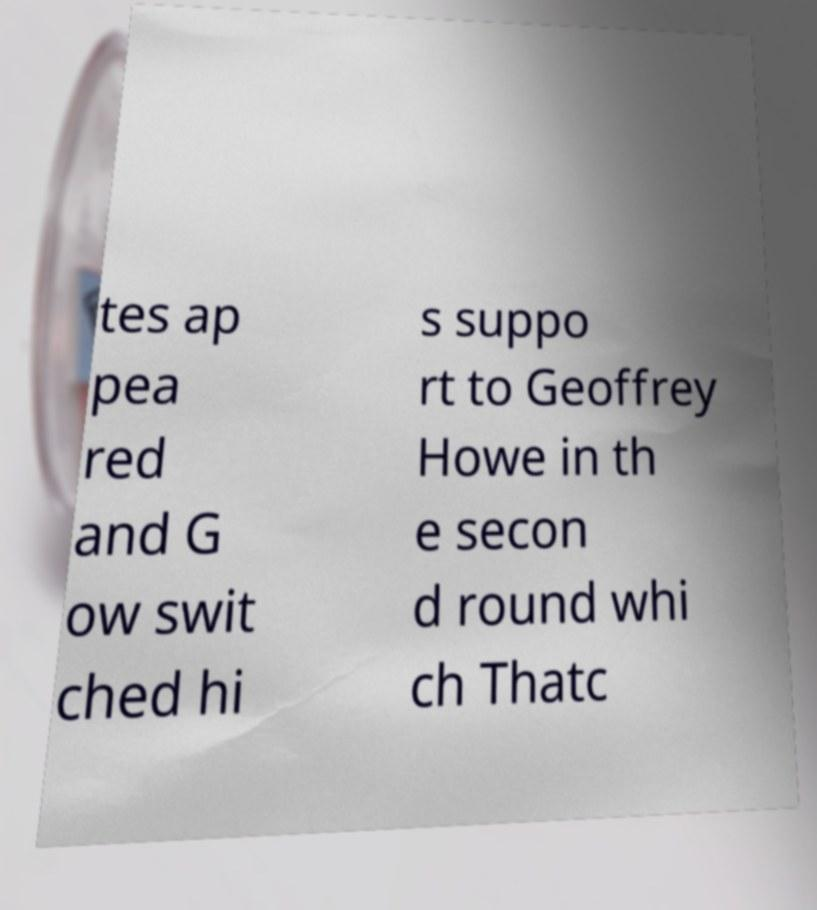Can you accurately transcribe the text from the provided image for me? tes ap pea red and G ow swit ched hi s suppo rt to Geoffrey Howe in th e secon d round whi ch Thatc 